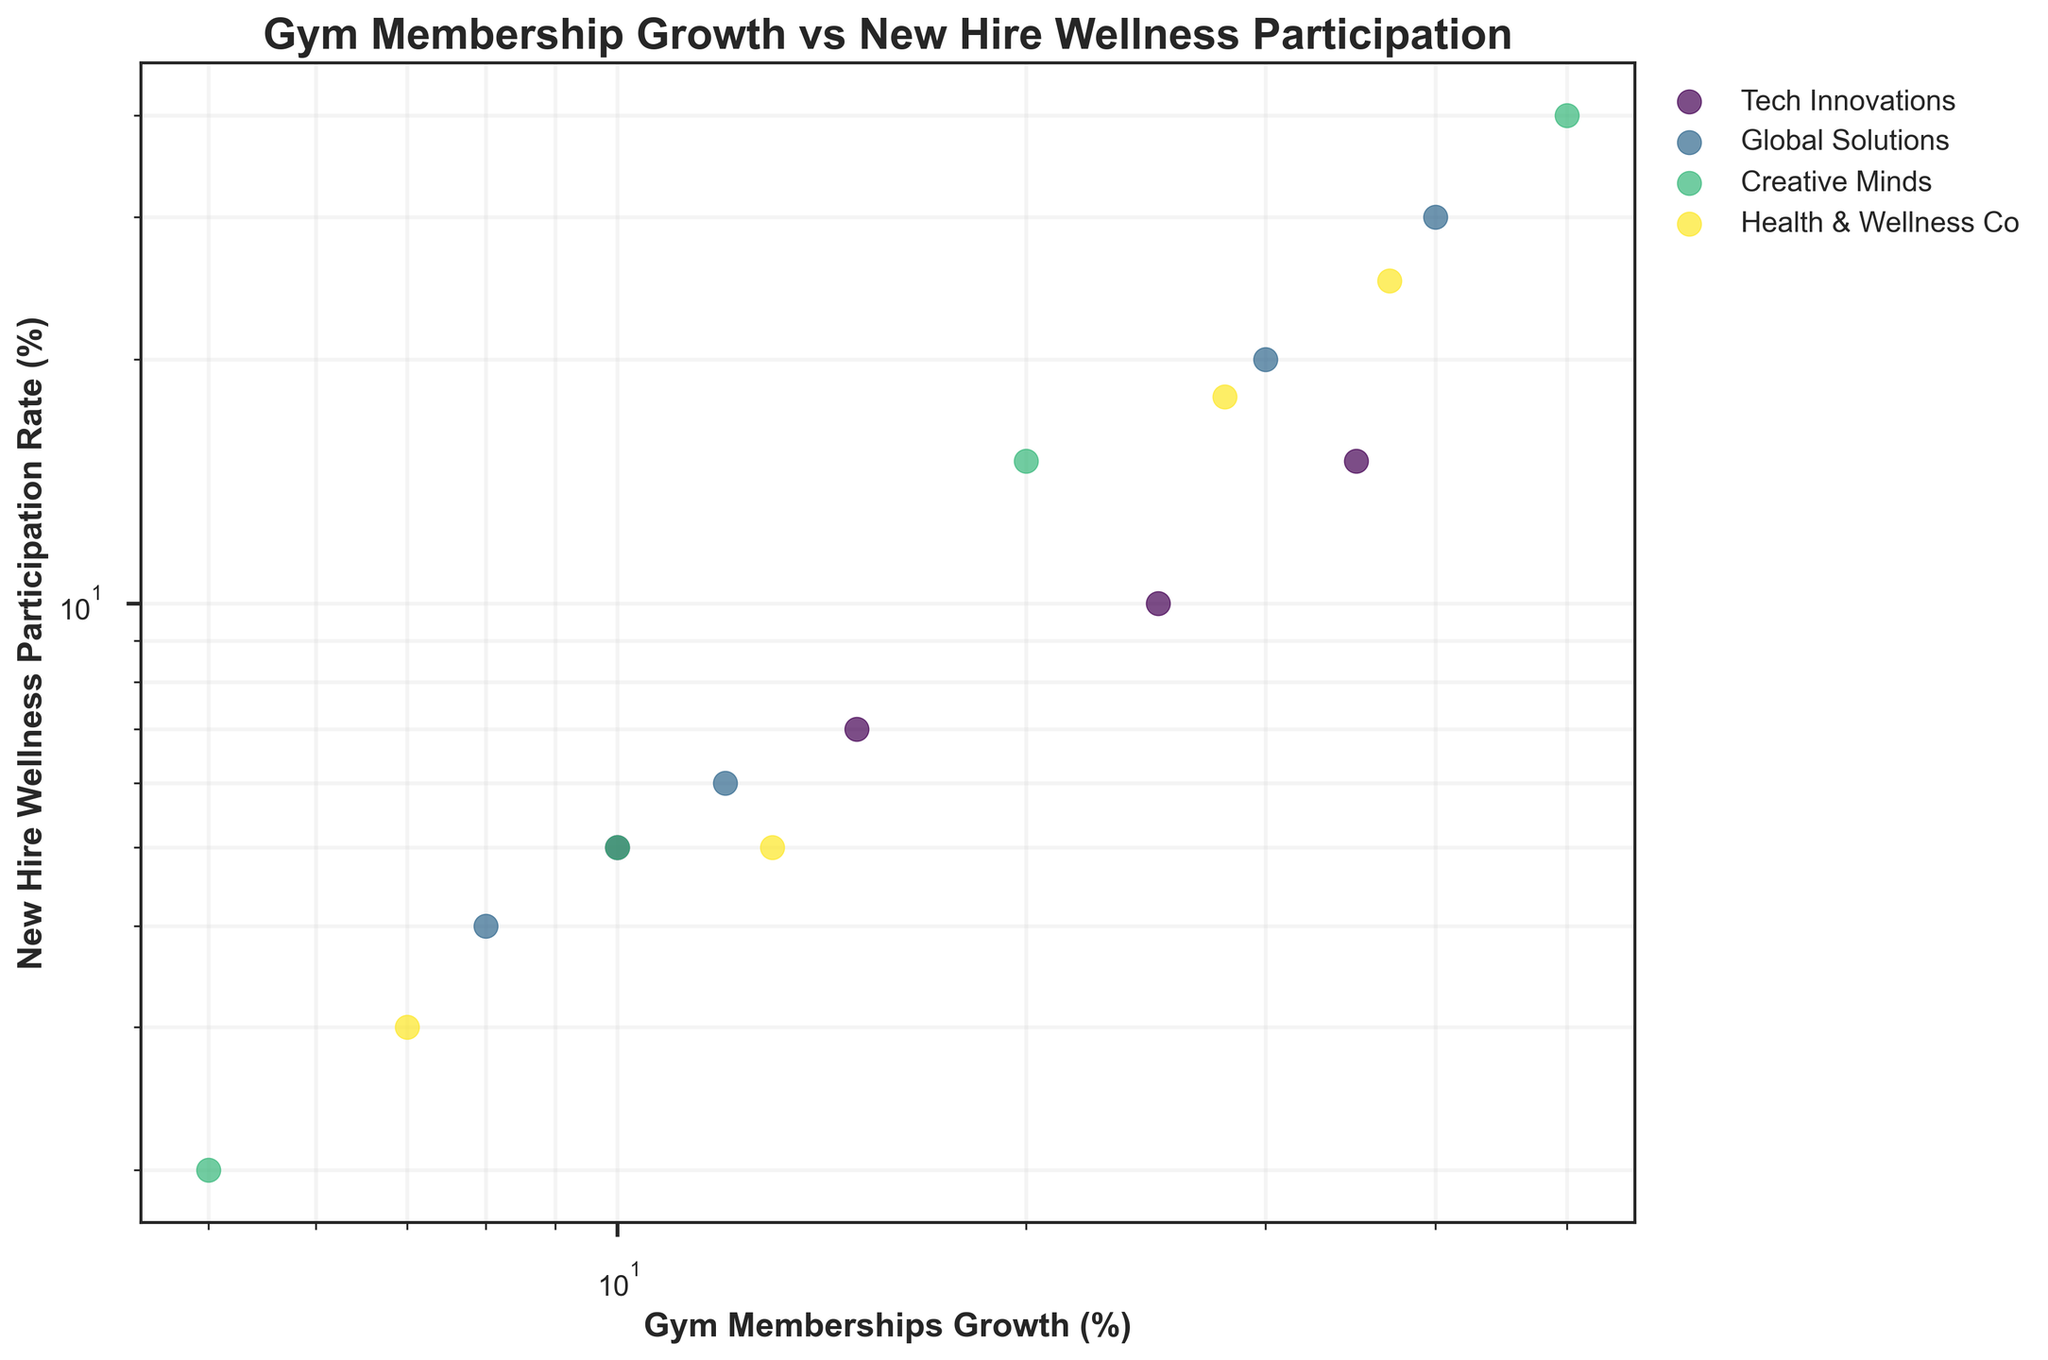What is the title of the figure? The title of the figure is typically at the top, describing what the plot is about. In this case, it is displayed as 'Gym Membership Growth vs New Hire Wellness Participation'.
Answer: Gym Membership Growth vs New Hire Wellness Participation What are the axes labels in the figure? The x-axis and y-axis labels are meaningful for understanding what each axis represents; here, the x-axis is labeled 'Gym Memberships Growth (%)' and the y-axis is labeled 'New Hire Wellness Participation Rate (%)'.
Answer: Gym Memberships Growth (%) and New Hire Wellness Participation Rate (%) Which company has the highest gym memberships growth rate in 2021? To find this, observe the data points for 2021 and identify which one has the highest x-coordinate, which represents gym memberships growth rate. Creative Minds has a value of 50%.
Answer: Creative Minds Among the four companies, which one showed the most significant increase in gym memberships growth from 2018 to 2021? Look at the change in gym memberships growth rates from 2018 to 2021 for each company. Creative Minds' growth rate increased from 5% to 50%, which is the highest increase (45 percentage points).
Answer: Creative Minds How do the participation rates in new hire wellness programs compare between Tech Innovations and Global Solutions in 2021? Find the data points for 2021 for both companies and check the y-coordinates for new hire wellness participation rates: Tech Innovations has 15% and Global Solutions has 30%.
Answer: Global Solutions has twice the participation rate of Tech Innovations Is there a visible trend in the relationship between gym memberships growth and new hire wellness participation rates? The log-log scatter plot indicates that as gym memberships growth increases, so does the new hire wellness participation rate. This suggests a positive correlation.
Answer: Positive correlation What is the gym memberships growth for Health & Wellness Co in 2019? Locate the data point for Health & Wellness Co in 2019. The x-coordinate indicates the gym memberships growth, which is 13%.
Answer: 13% Which company had the lowest new hire wellness participation rate in 2018? By checking the 2018 data points, Creative Minds has the lowest y-coordinate, with a participation rate of 2%.
Answer: Creative Minds Calculate the average gym memberships growth rate for Global Solutions over the four years shown. Add the Gym Memberships Growth (%) values for Global Solutions across the four years (8 + 12 + 30 + 40) and then divide by 4 to get the average: (8 + 12 + 30 + 40) / 4 = 22.5%.
Answer: 22.5% Could the increasing trend in gym memberships growth impact the overall workplace wellness? The positive correlation between gym memberships growth and wellness program participation suggests that as employees become more engaged in gym memberships, there's a potential increase in overall workplace wellness through higher engagement in wellness programs.
Answer: Yes, likely positive impact 